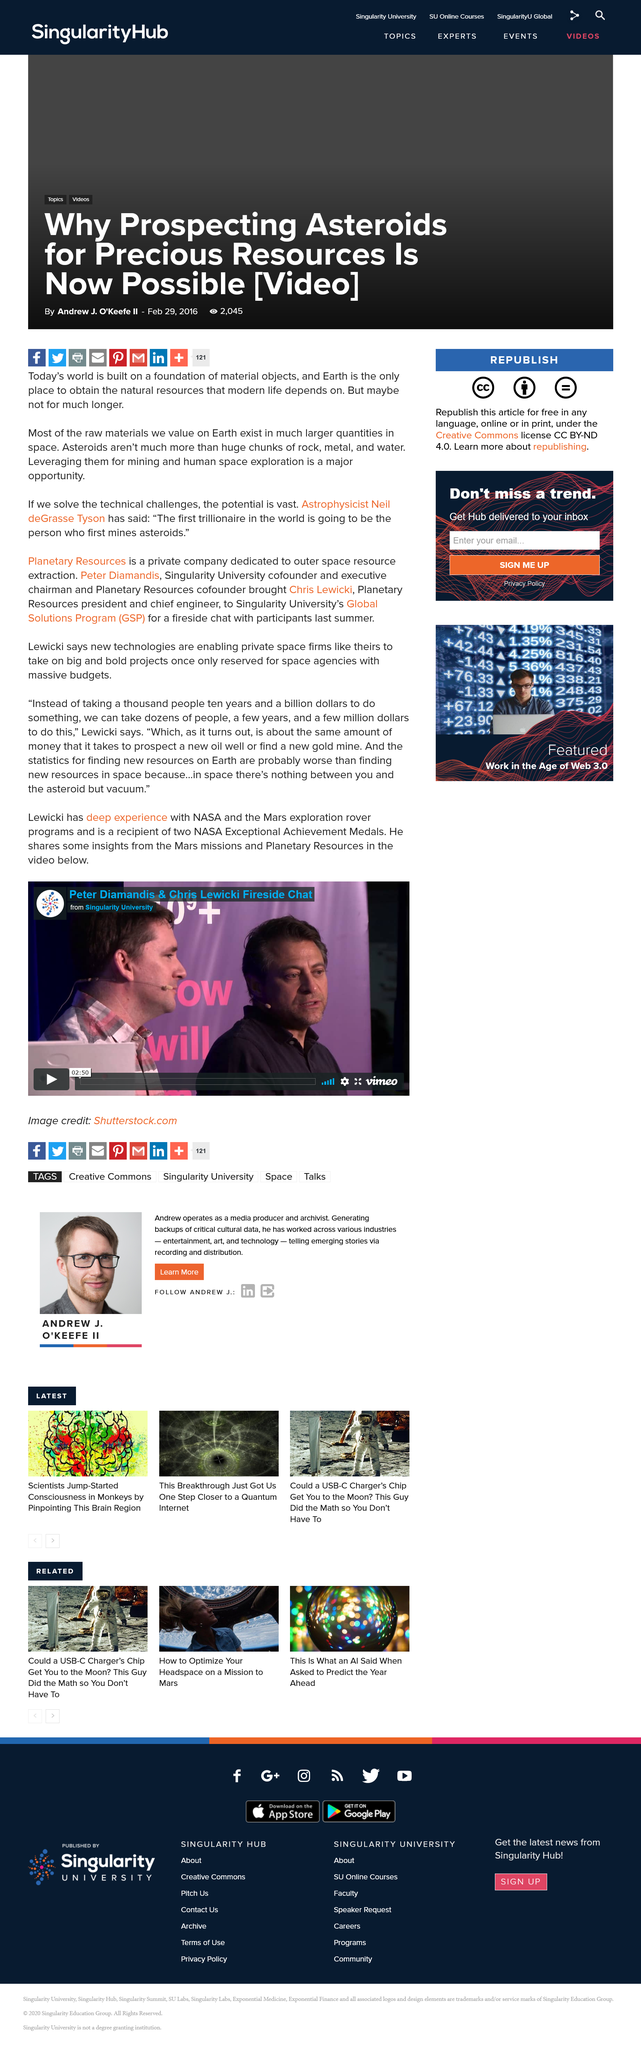Identify some key points in this picture. The person with extensive knowledge and involvement in the NASA and Mars exploration rover programs, named Chris Lewicki, is known for their in-depth expertise in these areas. A few million dollars is equivalent to the amount of money needed to prospect a new oil well or find a new gold mine. It is more likely to find resources in space than on Earth. 